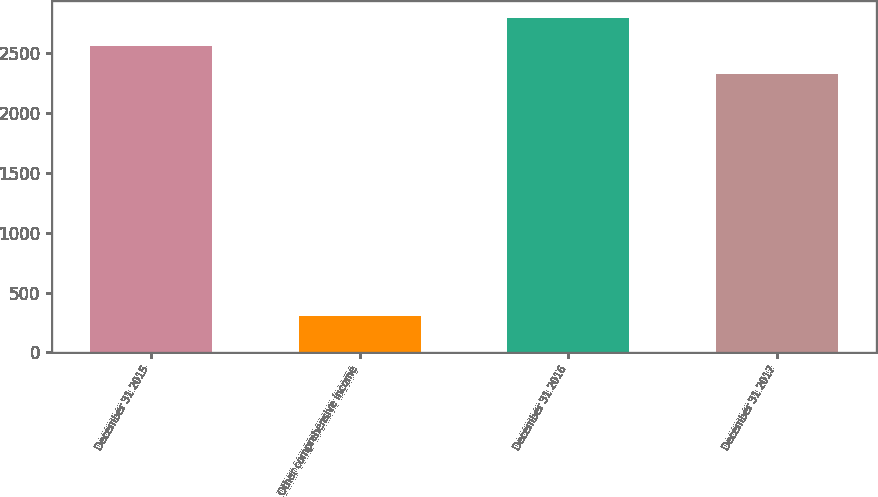Convert chart. <chart><loc_0><loc_0><loc_500><loc_500><bar_chart><fcel>December 31 2015<fcel>Other comprehensive income<fcel>December 31 2016<fcel>December 31 2017<nl><fcel>2564.2<fcel>301.2<fcel>2797.4<fcel>2331<nl></chart> 